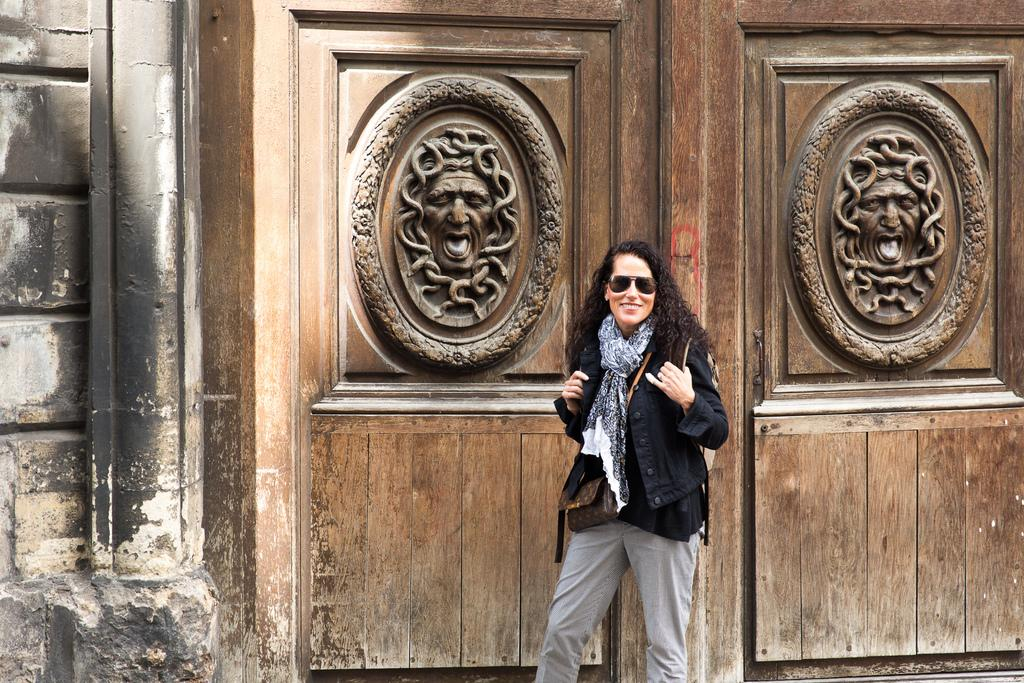Who is present in the image? There is a woman in the image. What is the woman's facial expression? The woman is smiling. What is the woman wearing on her face? The woman is wearing goggles. What is the woman wearing on her body? The woman is wearing bags. What can be seen in the background of the image? There is a wall and doors in the background of the image. What type of record can be seen on the wall in the image? There is no record present on the wall in the image. What type of shirt is the woman wearing in the image? The woman is not wearing a shirt in the image; she is wearing bags. 